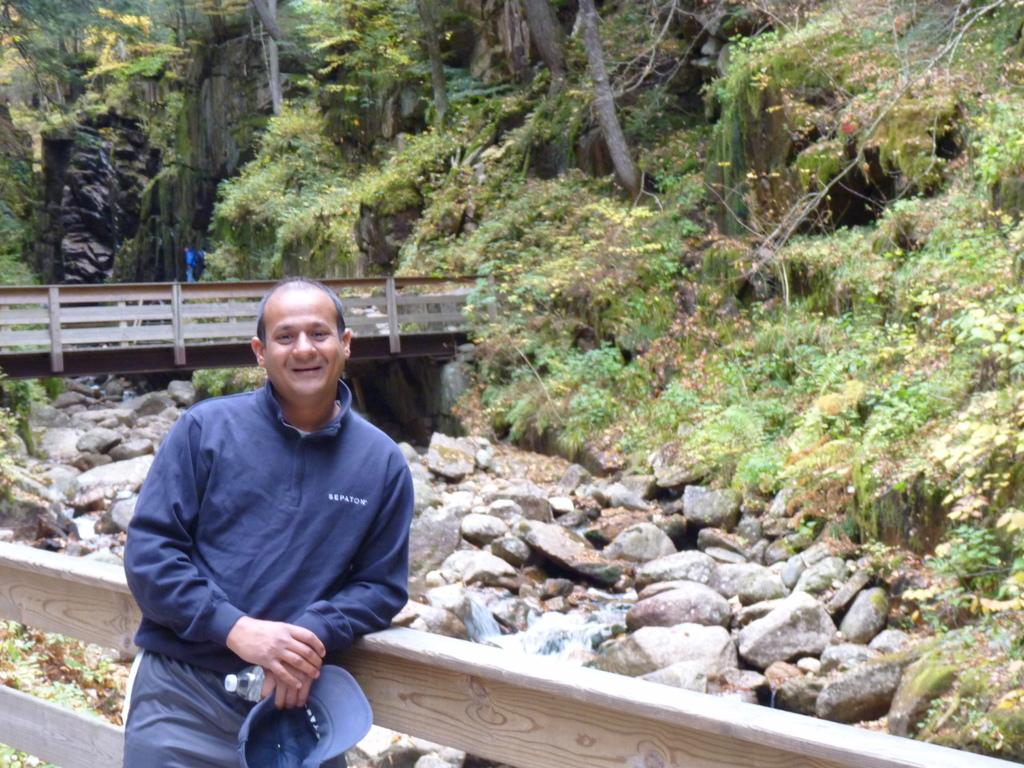What is the man in the image doing? The man is standing in the image. What is the man leaning on? The man is leaning on wooden grills. What type of natural elements can be seen in the image? Rocks and trees are present in the image. What can be seen in the background of the image? There is water visible in the image. Can you tell me how many boots are visible in the image? There are no boots present in the image. What type of guide is the man holding in the image? There is no guide visible in the image; the man is simply standing and leaning on wooden grills. 